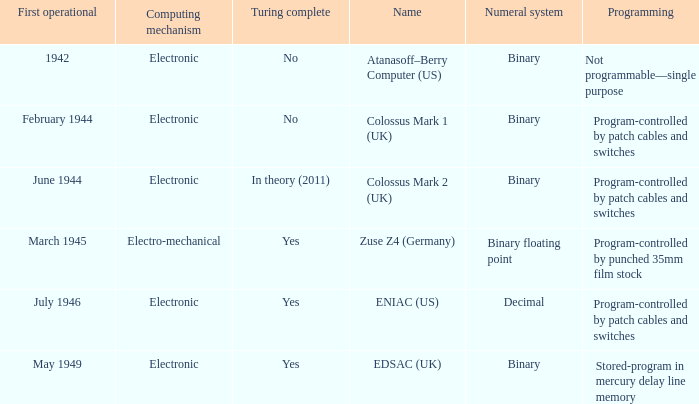What's the turing complete with numeral system being decimal Yes. 